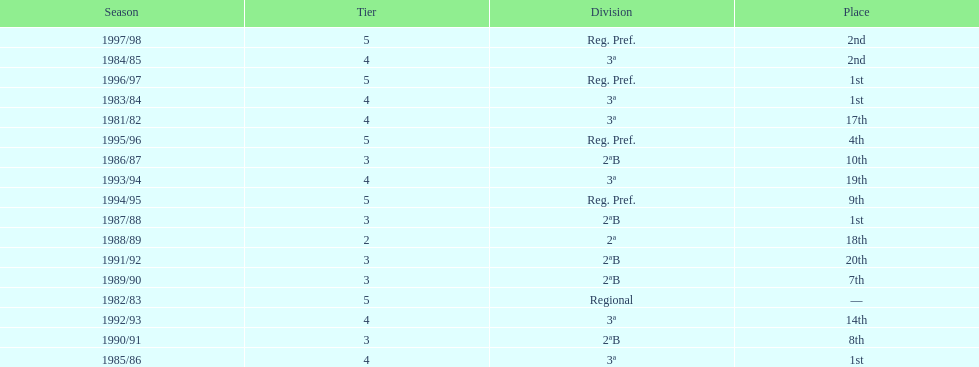How many times total did they finish first 4. 